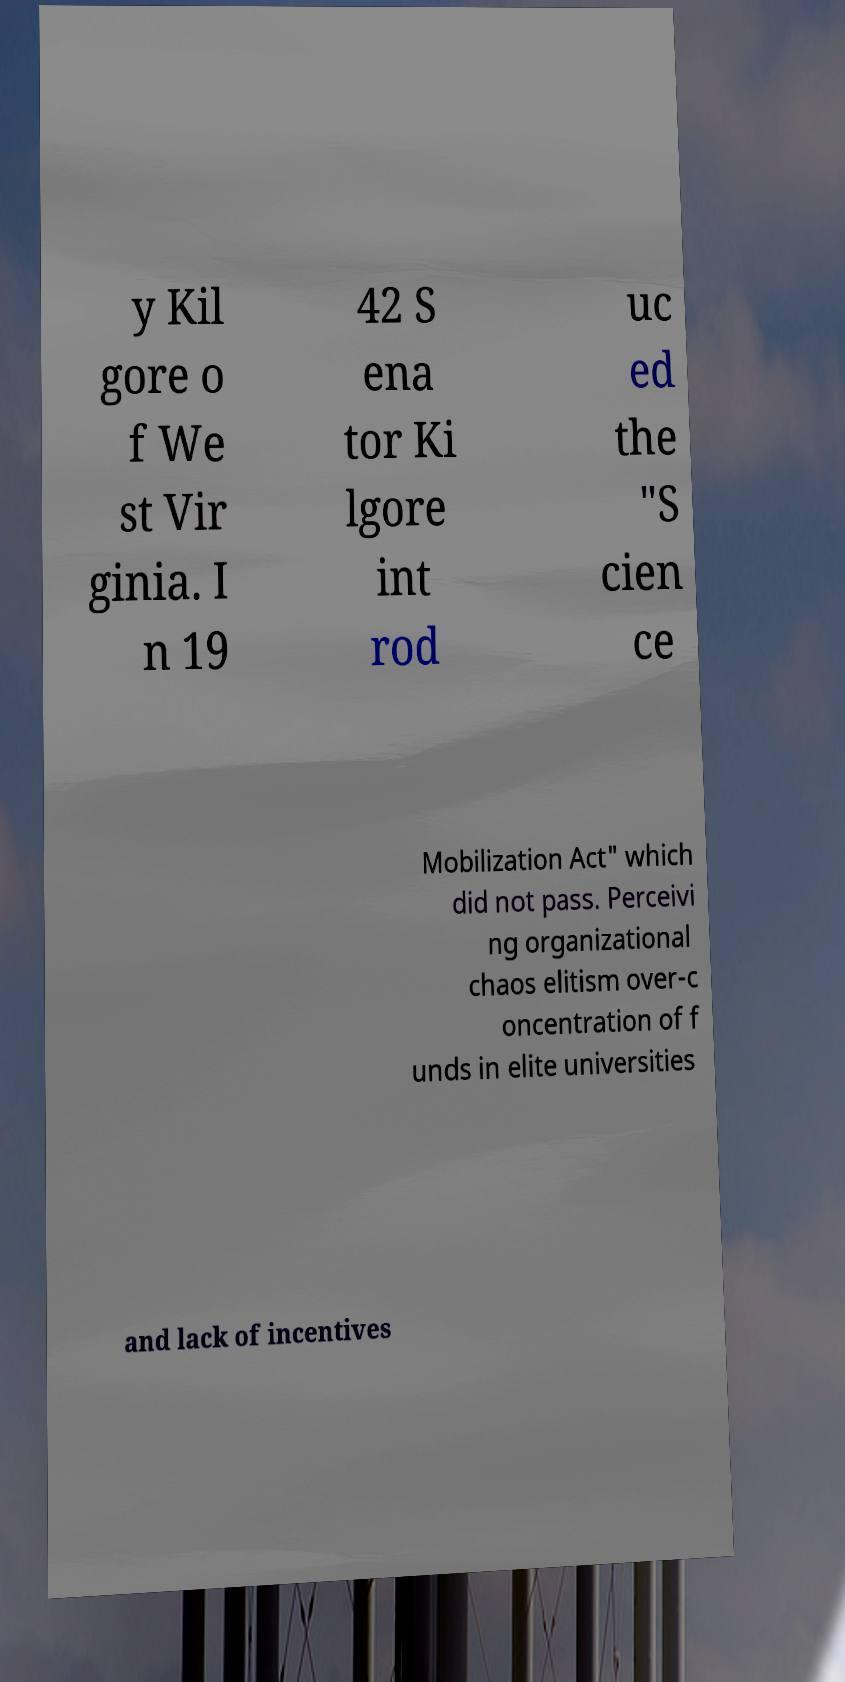Please read and relay the text visible in this image. What does it say? y Kil gore o f We st Vir ginia. I n 19 42 S ena tor Ki lgore int rod uc ed the "S cien ce Mobilization Act" which did not pass. Perceivi ng organizational chaos elitism over-c oncentration of f unds in elite universities and lack of incentives 